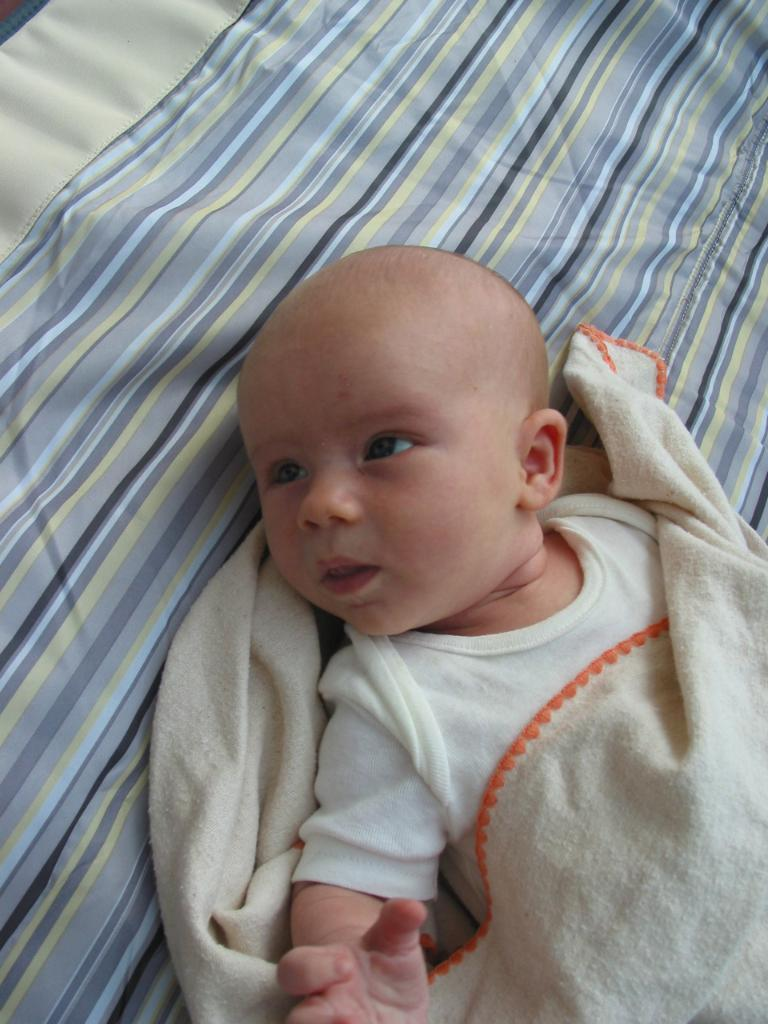What is the main subject of the image? There is a baby in the image. Where is the baby located? The baby is laying on a bed. What is covering the baby? There is a blanket on the baby. How many clocks can be seen in the image? There are no clocks present in the image. What type of way is the baby using to crush the blanket? The baby is not crushing the blanket, as it is laying on the bed with the blanket covering it. 